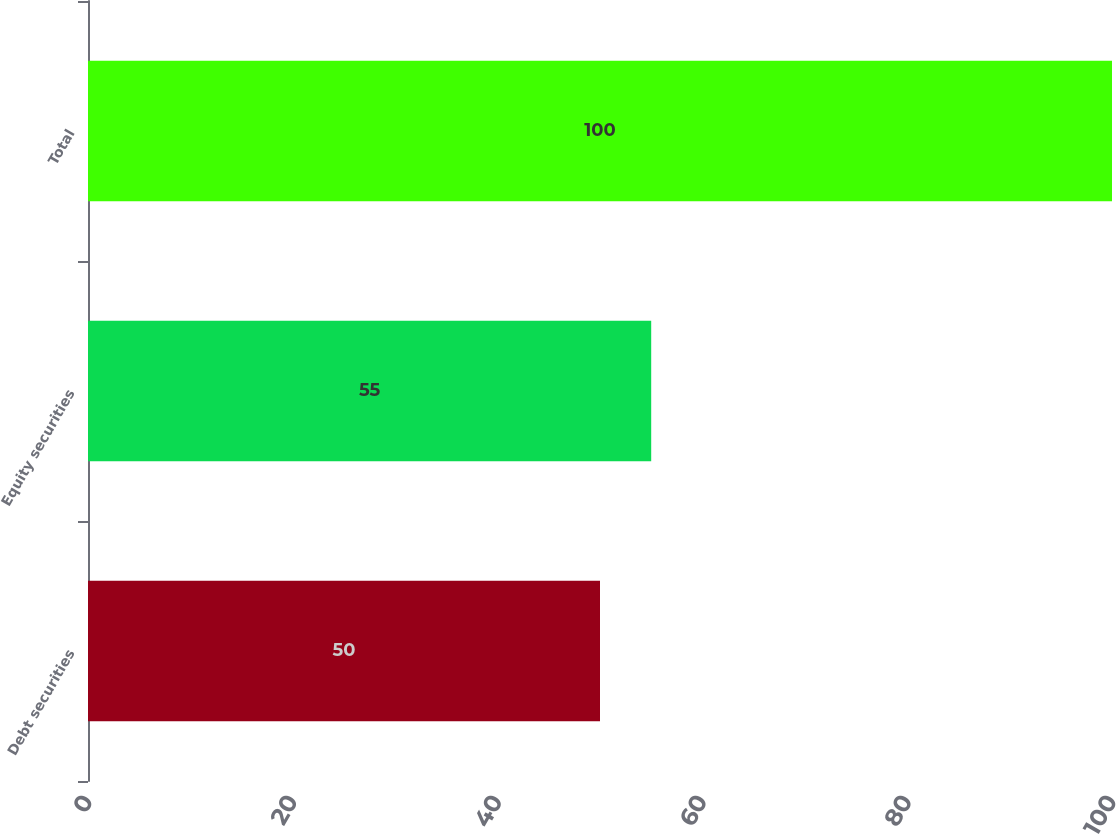Convert chart to OTSL. <chart><loc_0><loc_0><loc_500><loc_500><bar_chart><fcel>Debt securities<fcel>Equity securities<fcel>Total<nl><fcel>50<fcel>55<fcel>100<nl></chart> 